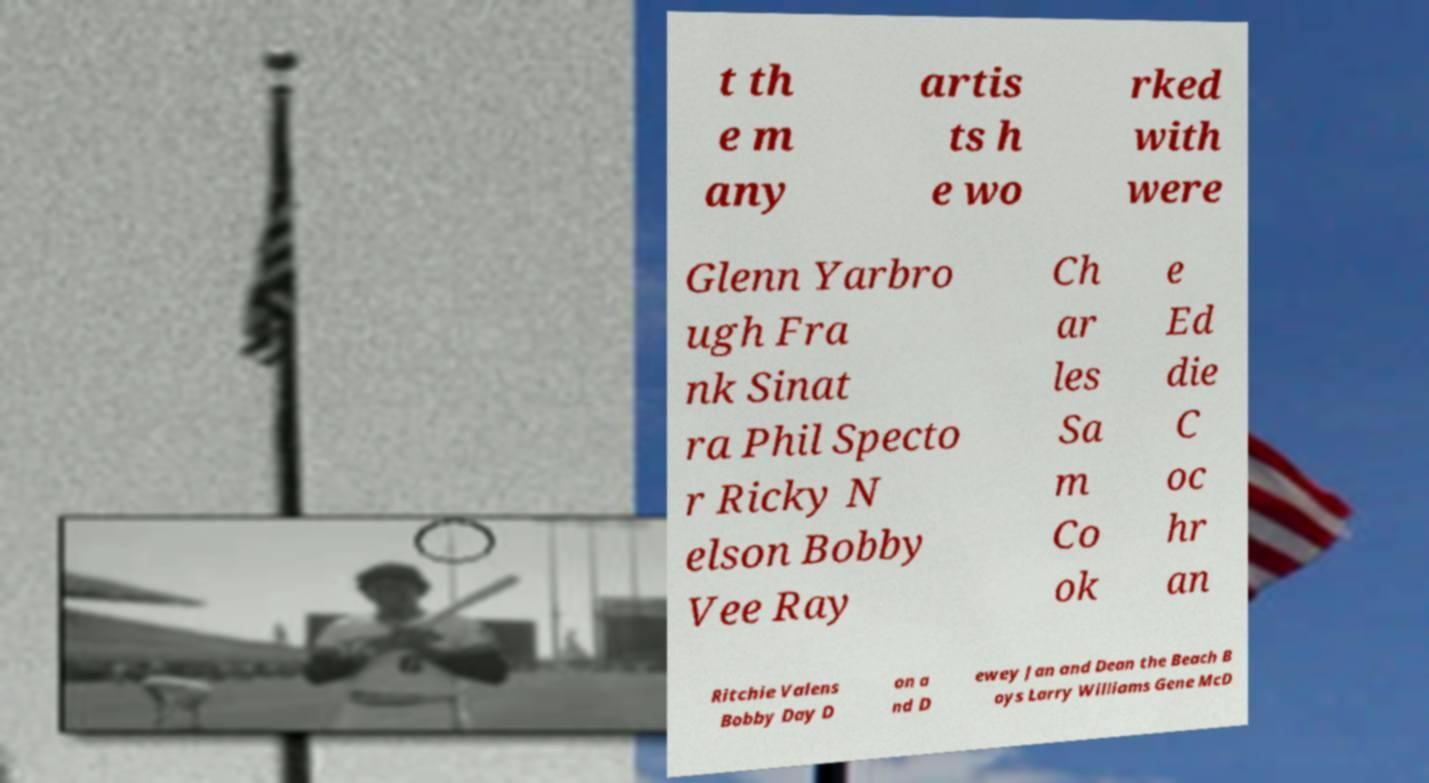Could you assist in decoding the text presented in this image and type it out clearly? t th e m any artis ts h e wo rked with were Glenn Yarbro ugh Fra nk Sinat ra Phil Specto r Ricky N elson Bobby Vee Ray Ch ar les Sa m Co ok e Ed die C oc hr an Ritchie Valens Bobby Day D on a nd D ewey Jan and Dean the Beach B oys Larry Williams Gene McD 